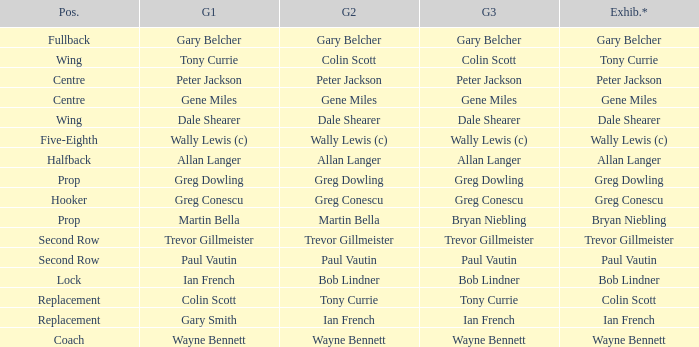What exhibition has greg conescu as game 1? Greg Conescu. 